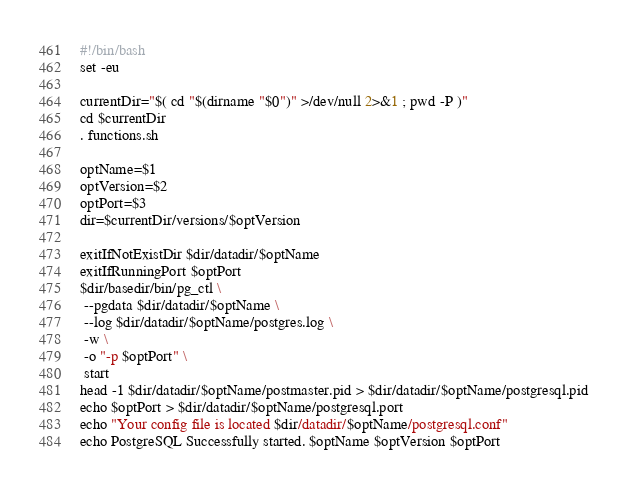<code> <loc_0><loc_0><loc_500><loc_500><_Bash_>#!/bin/bash
set -eu

currentDir="$( cd "$(dirname "$0")" >/dev/null 2>&1 ; pwd -P )"
cd $currentDir
. functions.sh

optName=$1
optVersion=$2
optPort=$3
dir=$currentDir/versions/$optVersion

exitIfNotExistDir $dir/datadir/$optName
exitIfRunningPort $optPort
$dir/basedir/bin/pg_ctl \
 --pgdata $dir/datadir/$optName \
 --log $dir/datadir/$optName/postgres.log \
 -w \
 -o "-p $optPort" \
 start
head -1 $dir/datadir/$optName/postmaster.pid > $dir/datadir/$optName/postgresql.pid
echo $optPort > $dir/datadir/$optName/postgresql.port
echo "Your config file is located $dir/datadir/$optName/postgresql.conf"
echo PostgreSQL Successfully started. $optName $optVersion $optPort
</code> 